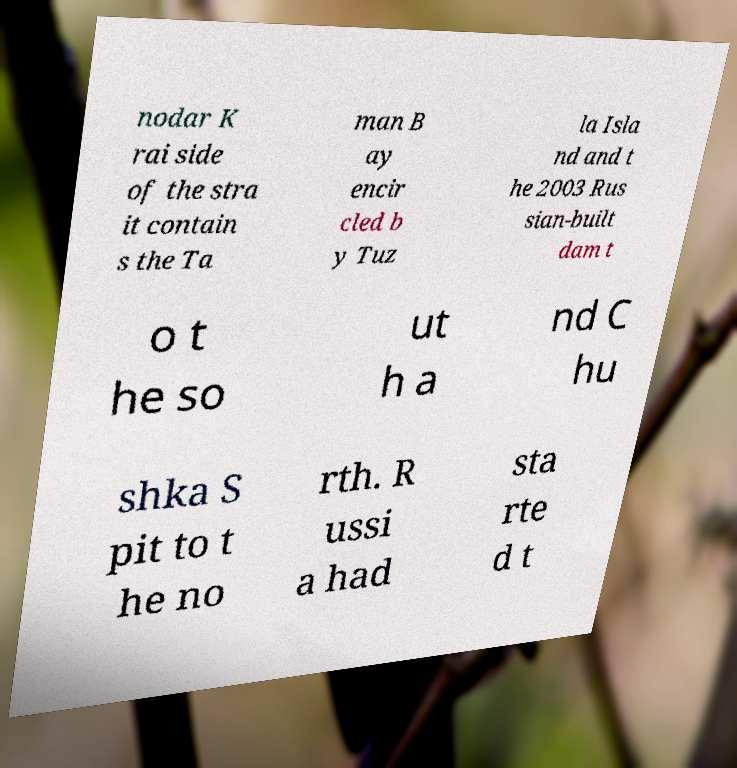Could you assist in decoding the text presented in this image and type it out clearly? nodar K rai side of the stra it contain s the Ta man B ay encir cled b y Tuz la Isla nd and t he 2003 Rus sian-built dam t o t he so ut h a nd C hu shka S pit to t he no rth. R ussi a had sta rte d t 